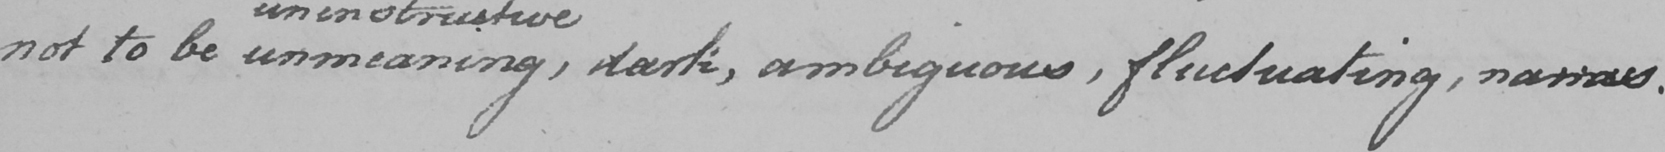Can you tell me what this handwritten text says? not to be unmeaning , dark , ambiguous , fluctuating , narrow , 